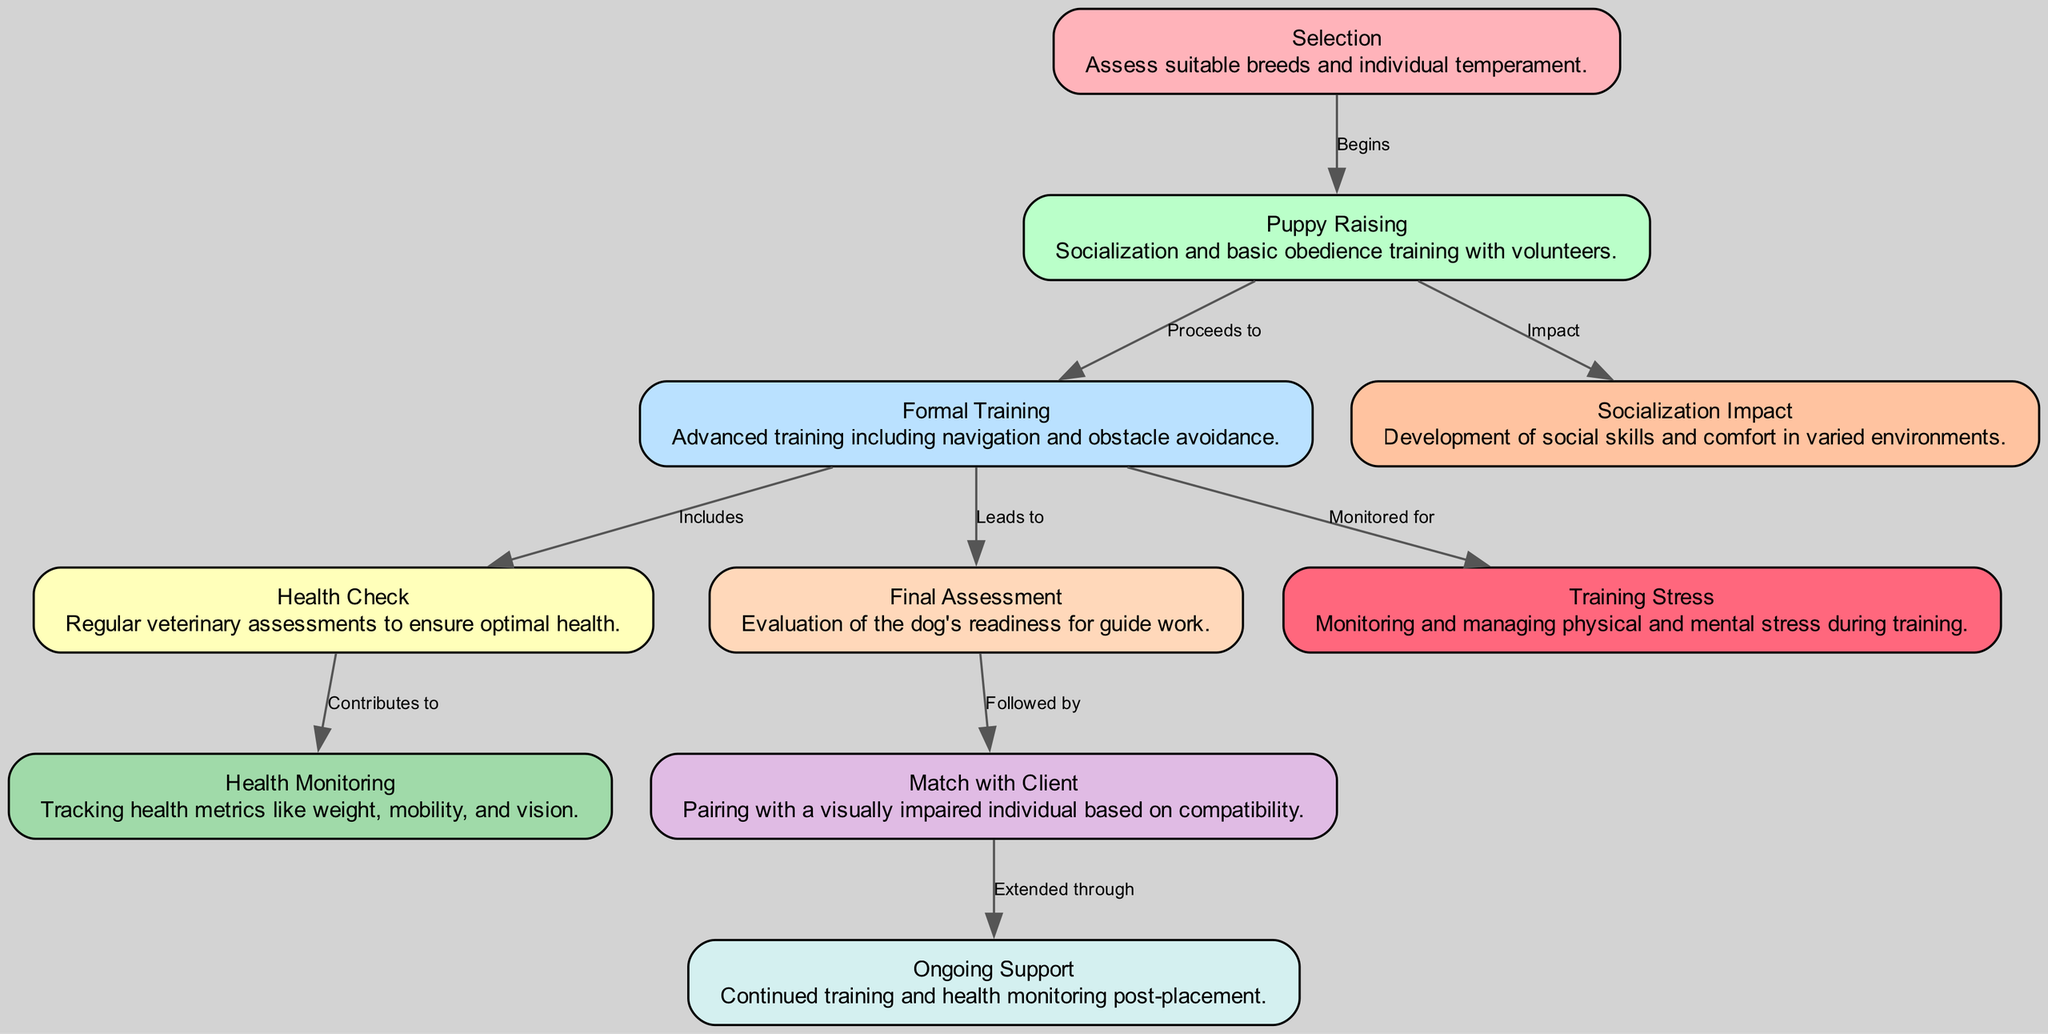What is the first phase of the guide dog training process? The diagram shows that the "Selection" phase is the starting point of the guide dog training process, which assesses suitable breeds and individual temperament.
Answer: Selection How many nodes are there in the diagram? By counting the nodes listed in the provided data, there are a total of 10 nodes representing different components of the guide dog training process.
Answer: 10 What follows the "Final Assessment" phase? According to the diagram, the "Match with Client" phase directly follows the "Final Assessment," where the evaluation of the dog's readiness leads to pairing with a visually impaired individual.
Answer: Match with Client Which node is connected to "Puppy Raising" to indicate its impact? The diagram indicates that "Socialization Impact" is connected to "Puppy Raising," showing the development of social skills and comfort in varied environments influenced by this phase.
Answer: Socialization Impact What type of training does "Formal Training" include? The "Formal Training" node details that it includes advanced training for navigation and obstacle avoidance, clearly describing the intensive training part of the process.
Answer: Advanced training What is monitored during the "Formal Training" phase? The diagram indicates that "Training Stress" is monitored for dogs during the "Formal Training," focusing on both physical and mental stress management throughout this critical training phase.
Answer: Training Stress What contributes to health monitoring in the guide dog training process? The connection from "Health Check" to "Health Monitoring" in the diagram indicates that regular veterinary assessments contribute to tracking health metrics like weight and mobility.
Answer: Health Monitoring What is the purpose of the "Ongoing Support" phase? The diagram outlines that "Ongoing Support" extends through the relationship established with the client after matching, providing continued training and health monitoring for the guide dog.
Answer: Continued training What leads from "Health Check" to another process in the diagram? "Health Check" leads to "Health Monitoring" in the diagram, illustrating the importance of regular veterinary assessments in maintaining the dog's optimal health.
Answer: Health Monitoring What is the last step in the guide dog training sequence? "Ongoing Support" is depicted as the final step in the sequence of training processes, occurring after the dog has been matched with a client, ensuring continued assistance and support.
Answer: Ongoing Support 